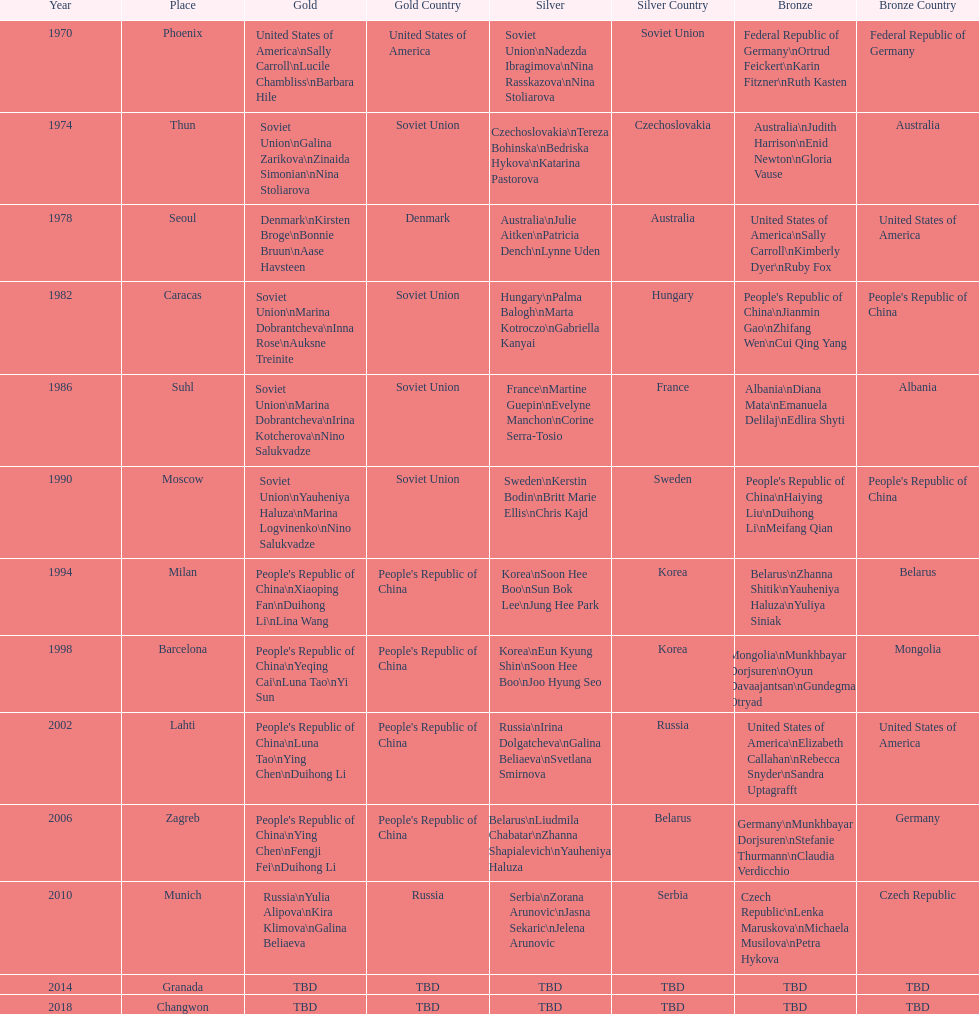Name one of the top three women to earn gold at the 1970 world championship held in phoenix, az Sally Carroll. Help me parse the entirety of this table. {'header': ['Year', 'Place', 'Gold', 'Gold Country', 'Silver', 'Silver Country', 'Bronze', 'Bronze Country'], 'rows': [['1970', 'Phoenix', 'United States of America\\nSally Carroll\\nLucile Chambliss\\nBarbara Hile', 'United States of America', 'Soviet Union\\nNadezda Ibragimova\\nNina Rasskazova\\nNina Stoliarova', 'Soviet Union', 'Federal Republic of Germany\\nOrtrud Feickert\\nKarin Fitzner\\nRuth Kasten', 'Federal Republic of Germany'], ['1974', 'Thun', 'Soviet Union\\nGalina Zarikova\\nZinaida Simonian\\nNina Stoliarova', 'Soviet Union', 'Czechoslovakia\\nTereza Bohinska\\nBedriska Hykova\\nKatarina Pastorova', 'Czechoslovakia', 'Australia\\nJudith Harrison\\nEnid Newton\\nGloria Vause', 'Australia'], ['1978', 'Seoul', 'Denmark\\nKirsten Broge\\nBonnie Bruun\\nAase Havsteen', 'Denmark', 'Australia\\nJulie Aitken\\nPatricia Dench\\nLynne Uden', 'Australia', 'United States of America\\nSally Carroll\\nKimberly Dyer\\nRuby Fox', 'United States of America'], ['1982', 'Caracas', 'Soviet Union\\nMarina Dobrantcheva\\nInna Rose\\nAuksne Treinite', 'Soviet Union', 'Hungary\\nPalma Balogh\\nMarta Kotroczo\\nGabriella Kanyai', 'Hungary', "People's Republic of China\\nJianmin Gao\\nZhifang Wen\\nCui Qing Yang", "People's Republic of China"], ['1986', 'Suhl', 'Soviet Union\\nMarina Dobrantcheva\\nIrina Kotcherova\\nNino Salukvadze', 'Soviet Union', 'France\\nMartine Guepin\\nEvelyne Manchon\\nCorine Serra-Tosio', 'France', 'Albania\\nDiana Mata\\nEmanuela Delilaj\\nEdlira Shyti', 'Albania'], ['1990', 'Moscow', 'Soviet Union\\nYauheniya Haluza\\nMarina Logvinenko\\nNino Salukvadze', 'Soviet Union', 'Sweden\\nKerstin Bodin\\nBritt Marie Ellis\\nChris Kajd', 'Sweden', "People's Republic of China\\nHaiying Liu\\nDuihong Li\\nMeifang Qian", "People's Republic of China"], ['1994', 'Milan', "People's Republic of China\\nXiaoping Fan\\nDuihong Li\\nLina Wang", "People's Republic of China", 'Korea\\nSoon Hee Boo\\nSun Bok Lee\\nJung Hee Park', 'Korea', 'Belarus\\nZhanna Shitik\\nYauheniya Haluza\\nYuliya Siniak', 'Belarus'], ['1998', 'Barcelona', "People's Republic of China\\nYeqing Cai\\nLuna Tao\\nYi Sun", "People's Republic of China", 'Korea\\nEun Kyung Shin\\nSoon Hee Boo\\nJoo Hyung Seo', 'Korea', 'Mongolia\\nMunkhbayar Dorjsuren\\nOyun Davaajantsan\\nGundegmaa Otryad', 'Mongolia'], ['2002', 'Lahti', "People's Republic of China\\nLuna Tao\\nYing Chen\\nDuihong Li", "People's Republic of China", 'Russia\\nIrina Dolgatcheva\\nGalina Beliaeva\\nSvetlana Smirnova', 'Russia', 'United States of America\\nElizabeth Callahan\\nRebecca Snyder\\nSandra Uptagrafft', 'United States of America'], ['2006', 'Zagreb', "People's Republic of China\\nYing Chen\\nFengji Fei\\nDuihong Li", "People's Republic of China", 'Belarus\\nLiudmila Chabatar\\nZhanna Shapialevich\\nYauheniya Haluza', 'Belarus', 'Germany\\nMunkhbayar Dorjsuren\\nStefanie Thurmann\\nClaudia Verdicchio', 'Germany'], ['2010', 'Munich', 'Russia\\nYulia Alipova\\nKira Klimova\\nGalina Beliaeva', 'Russia', 'Serbia\\nZorana Arunovic\\nJasna Sekaric\\nJelena Arunovic', 'Serbia', 'Czech Republic\\nLenka Maruskova\\nMichaela Musilova\\nPetra Hykova', 'Czech Republic'], ['2014', 'Granada', 'TBD', 'TBD', 'TBD', 'TBD', 'TBD', 'TBD'], ['2018', 'Changwon', 'TBD', 'TBD', 'TBD', 'TBD', 'TBD', 'TBD']]} 